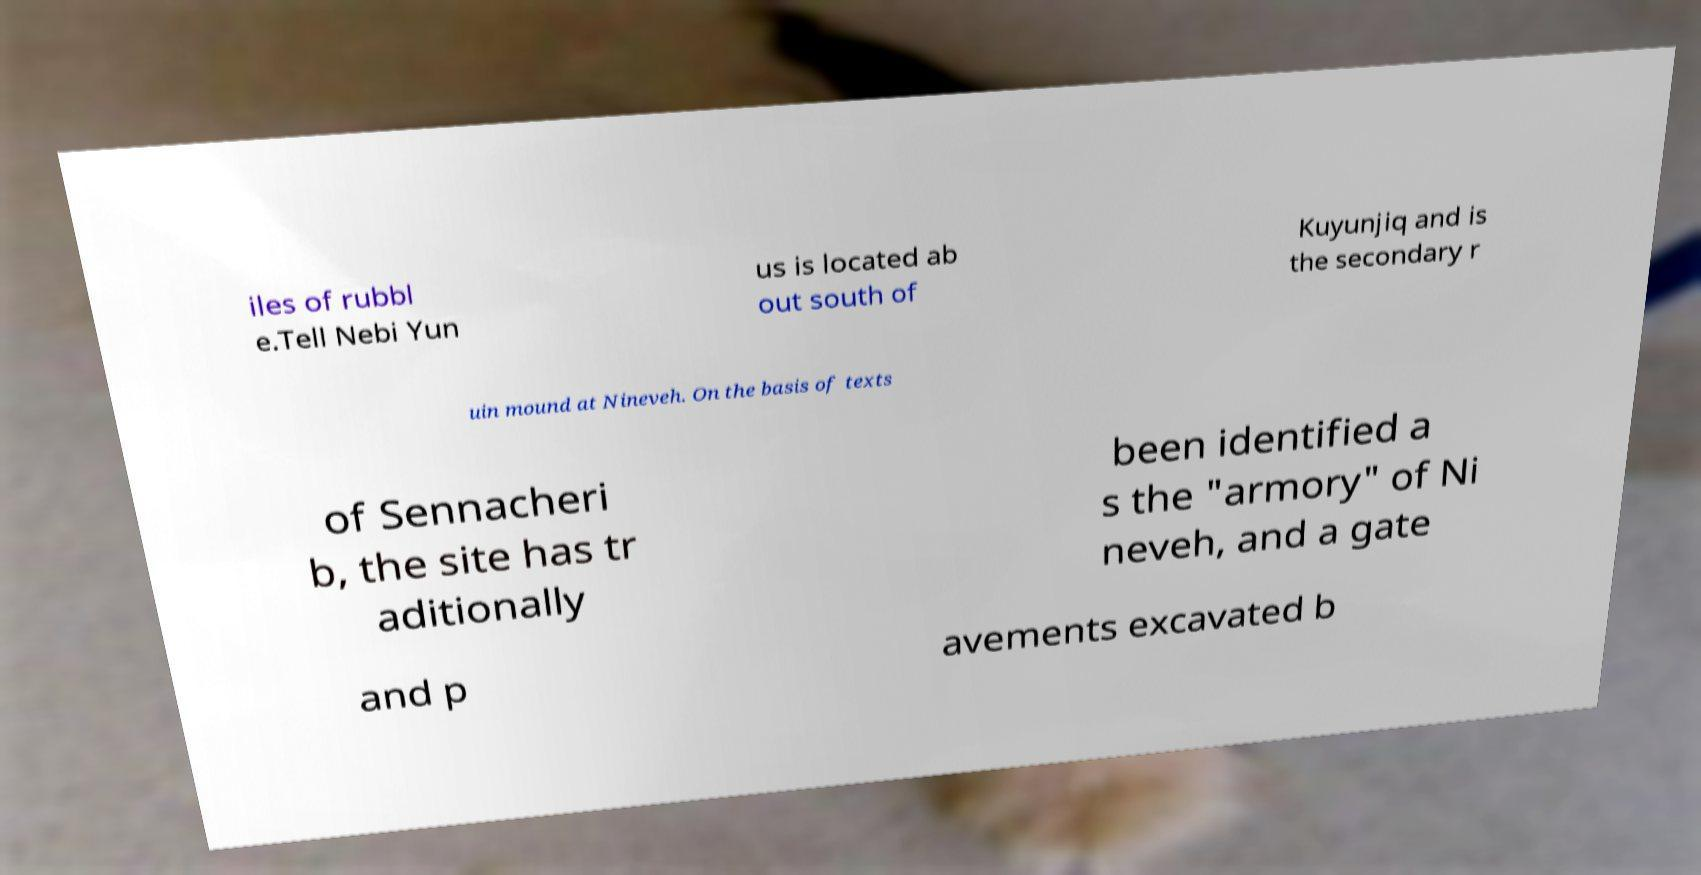What messages or text are displayed in this image? I need them in a readable, typed format. iles of rubbl e.Tell Nebi Yun us is located ab out south of Kuyunjiq and is the secondary r uin mound at Nineveh. On the basis of texts of Sennacheri b, the site has tr aditionally been identified a s the "armory" of Ni neveh, and a gate and p avements excavated b 